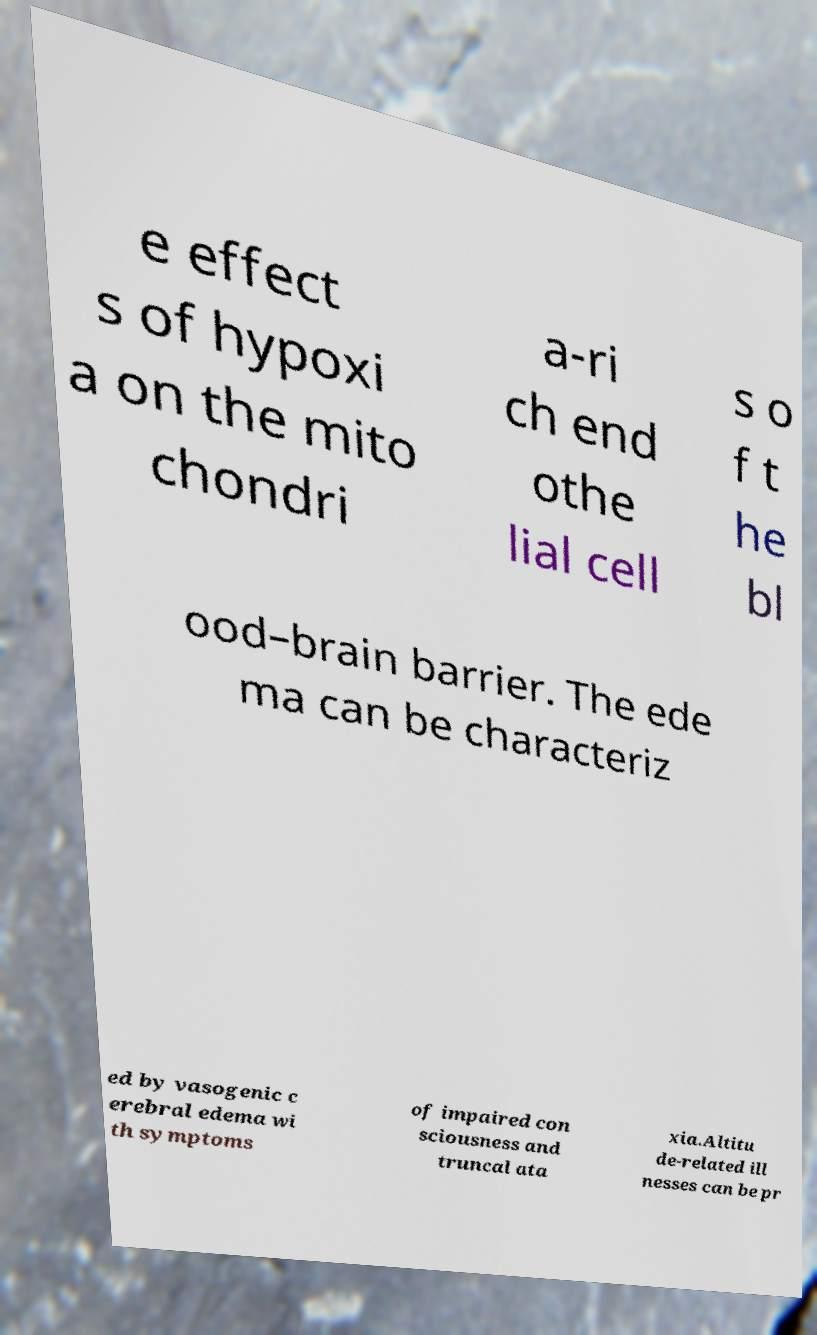What messages or text are displayed in this image? I need them in a readable, typed format. e effect s of hypoxi a on the mito chondri a-ri ch end othe lial cell s o f t he bl ood–brain barrier. The ede ma can be characteriz ed by vasogenic c erebral edema wi th symptoms of impaired con sciousness and truncal ata xia.Altitu de-related ill nesses can be pr 